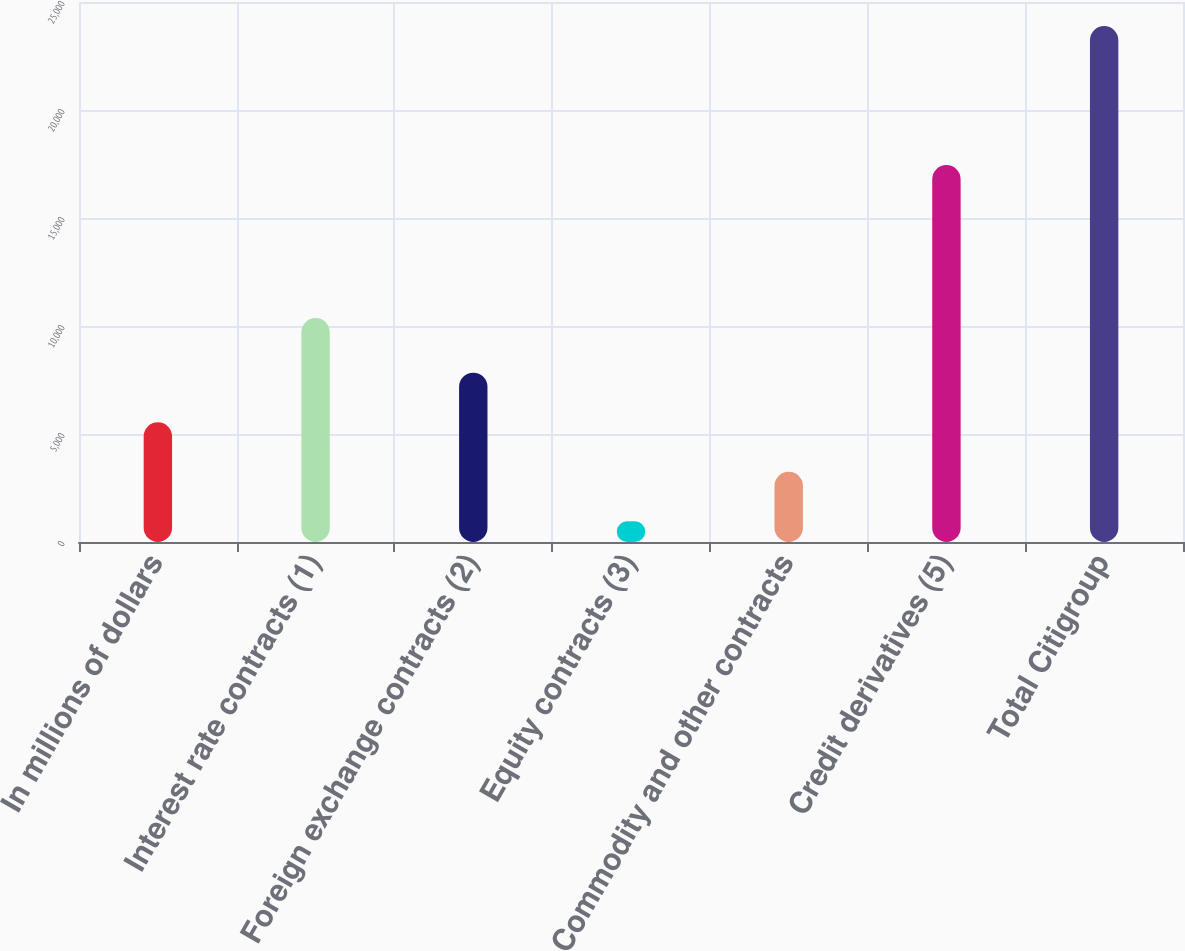<chart> <loc_0><loc_0><loc_500><loc_500><bar_chart><fcel>In millions of dollars<fcel>Interest rate contracts (1)<fcel>Foreign exchange contracts (2)<fcel>Equity contracts (3)<fcel>Commodity and other contracts<fcel>Credit derivatives (5)<fcel>Total Citigroup<nl><fcel>5544.2<fcel>10369<fcel>7837.3<fcel>958<fcel>3251.1<fcel>17453<fcel>23889<nl></chart> 